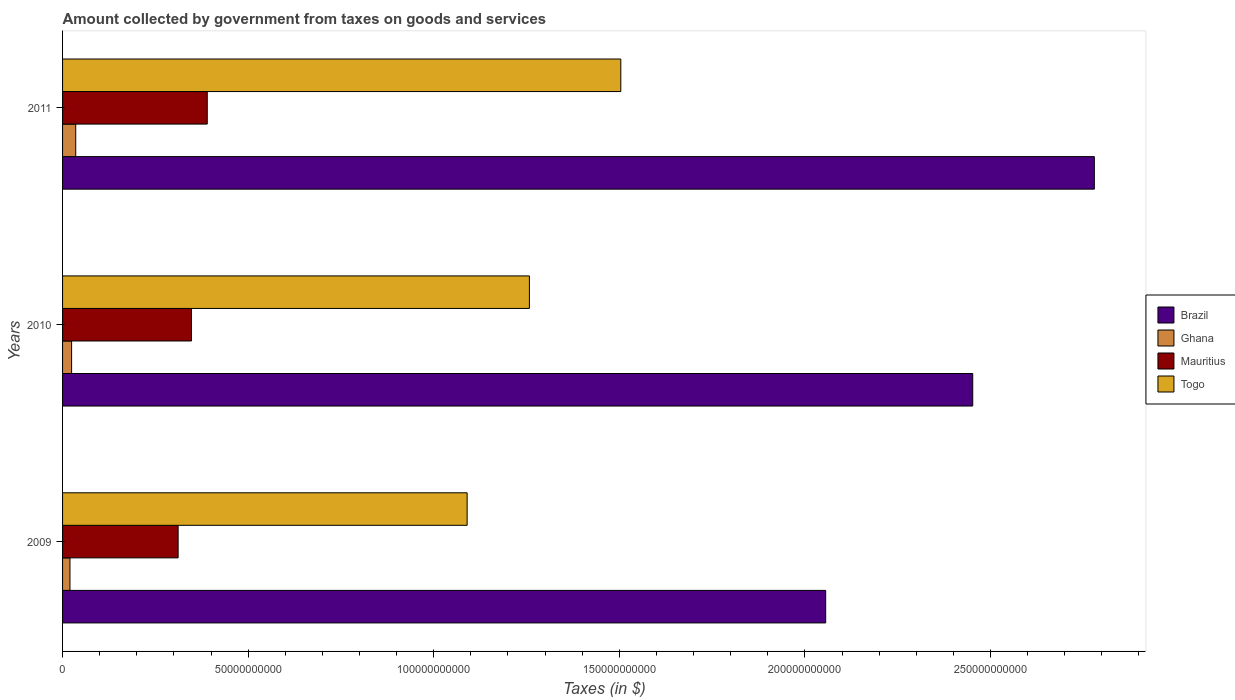How many different coloured bars are there?
Ensure brevity in your answer.  4. How many groups of bars are there?
Provide a short and direct response. 3. Are the number of bars on each tick of the Y-axis equal?
Provide a succinct answer. Yes. How many bars are there on the 3rd tick from the top?
Your response must be concise. 4. What is the label of the 3rd group of bars from the top?
Make the answer very short. 2009. What is the amount collected by government from taxes on goods and services in Togo in 2009?
Your answer should be very brief. 1.09e+11. Across all years, what is the maximum amount collected by government from taxes on goods and services in Mauritius?
Offer a terse response. 3.90e+1. Across all years, what is the minimum amount collected by government from taxes on goods and services in Mauritius?
Offer a very short reply. 3.11e+1. What is the total amount collected by government from taxes on goods and services in Brazil in the graph?
Your answer should be very brief. 7.29e+11. What is the difference between the amount collected by government from taxes on goods and services in Mauritius in 2010 and that in 2011?
Offer a terse response. -4.25e+09. What is the difference between the amount collected by government from taxes on goods and services in Brazil in 2010 and the amount collected by government from taxes on goods and services in Togo in 2011?
Provide a succinct answer. 9.48e+1. What is the average amount collected by government from taxes on goods and services in Mauritius per year?
Give a very brief answer. 3.50e+1. In the year 2010, what is the difference between the amount collected by government from taxes on goods and services in Togo and amount collected by government from taxes on goods and services in Mauritius?
Make the answer very short. 9.10e+1. What is the ratio of the amount collected by government from taxes on goods and services in Mauritius in 2009 to that in 2010?
Provide a succinct answer. 0.9. Is the amount collected by government from taxes on goods and services in Togo in 2010 less than that in 2011?
Offer a very short reply. Yes. What is the difference between the highest and the second highest amount collected by government from taxes on goods and services in Ghana?
Your response must be concise. 1.11e+09. What is the difference between the highest and the lowest amount collected by government from taxes on goods and services in Ghana?
Offer a terse response. 1.55e+09. Is the sum of the amount collected by government from taxes on goods and services in Mauritius in 2009 and 2010 greater than the maximum amount collected by government from taxes on goods and services in Togo across all years?
Your response must be concise. No. Is it the case that in every year, the sum of the amount collected by government from taxes on goods and services in Ghana and amount collected by government from taxes on goods and services in Togo is greater than the sum of amount collected by government from taxes on goods and services in Brazil and amount collected by government from taxes on goods and services in Mauritius?
Ensure brevity in your answer.  Yes. What does the 1st bar from the top in 2009 represents?
Provide a succinct answer. Togo. What does the 4th bar from the bottom in 2010 represents?
Offer a very short reply. Togo. Is it the case that in every year, the sum of the amount collected by government from taxes on goods and services in Togo and amount collected by government from taxes on goods and services in Mauritius is greater than the amount collected by government from taxes on goods and services in Brazil?
Ensure brevity in your answer.  No. Are all the bars in the graph horizontal?
Provide a short and direct response. Yes. How many years are there in the graph?
Offer a very short reply. 3. Does the graph contain grids?
Make the answer very short. No. Where does the legend appear in the graph?
Offer a terse response. Center right. What is the title of the graph?
Provide a short and direct response. Amount collected by government from taxes on goods and services. What is the label or title of the X-axis?
Your response must be concise. Taxes (in $). What is the Taxes (in $) in Brazil in 2009?
Offer a very short reply. 2.06e+11. What is the Taxes (in $) of Ghana in 2009?
Ensure brevity in your answer.  2.00e+09. What is the Taxes (in $) in Mauritius in 2009?
Make the answer very short. 3.11e+1. What is the Taxes (in $) in Togo in 2009?
Provide a succinct answer. 1.09e+11. What is the Taxes (in $) of Brazil in 2010?
Offer a terse response. 2.45e+11. What is the Taxes (in $) in Ghana in 2010?
Ensure brevity in your answer.  2.44e+09. What is the Taxes (in $) in Mauritius in 2010?
Your answer should be very brief. 3.47e+1. What is the Taxes (in $) in Togo in 2010?
Give a very brief answer. 1.26e+11. What is the Taxes (in $) of Brazil in 2011?
Your answer should be compact. 2.78e+11. What is the Taxes (in $) in Ghana in 2011?
Your answer should be very brief. 3.55e+09. What is the Taxes (in $) of Mauritius in 2011?
Give a very brief answer. 3.90e+1. What is the Taxes (in $) in Togo in 2011?
Ensure brevity in your answer.  1.50e+11. Across all years, what is the maximum Taxes (in $) in Brazil?
Offer a very short reply. 2.78e+11. Across all years, what is the maximum Taxes (in $) of Ghana?
Offer a very short reply. 3.55e+09. Across all years, what is the maximum Taxes (in $) of Mauritius?
Offer a very short reply. 3.90e+1. Across all years, what is the maximum Taxes (in $) of Togo?
Give a very brief answer. 1.50e+11. Across all years, what is the minimum Taxes (in $) in Brazil?
Your answer should be compact. 2.06e+11. Across all years, what is the minimum Taxes (in $) of Ghana?
Make the answer very short. 2.00e+09. Across all years, what is the minimum Taxes (in $) in Mauritius?
Provide a short and direct response. 3.11e+1. Across all years, what is the minimum Taxes (in $) in Togo?
Provide a short and direct response. 1.09e+11. What is the total Taxes (in $) of Brazil in the graph?
Your answer should be compact. 7.29e+11. What is the total Taxes (in $) in Ghana in the graph?
Your answer should be very brief. 7.98e+09. What is the total Taxes (in $) of Mauritius in the graph?
Give a very brief answer. 1.05e+11. What is the total Taxes (in $) of Togo in the graph?
Offer a terse response. 3.85e+11. What is the difference between the Taxes (in $) of Brazil in 2009 and that in 2010?
Keep it short and to the point. -3.96e+1. What is the difference between the Taxes (in $) in Ghana in 2009 and that in 2010?
Your response must be concise. -4.40e+08. What is the difference between the Taxes (in $) of Mauritius in 2009 and that in 2010?
Offer a very short reply. -3.60e+09. What is the difference between the Taxes (in $) of Togo in 2009 and that in 2010?
Your answer should be very brief. -1.68e+1. What is the difference between the Taxes (in $) in Brazil in 2009 and that in 2011?
Give a very brief answer. -7.24e+1. What is the difference between the Taxes (in $) in Ghana in 2009 and that in 2011?
Ensure brevity in your answer.  -1.55e+09. What is the difference between the Taxes (in $) of Mauritius in 2009 and that in 2011?
Your response must be concise. -7.85e+09. What is the difference between the Taxes (in $) of Togo in 2009 and that in 2011?
Offer a very short reply. -4.14e+1. What is the difference between the Taxes (in $) in Brazil in 2010 and that in 2011?
Make the answer very short. -3.28e+1. What is the difference between the Taxes (in $) of Ghana in 2010 and that in 2011?
Your answer should be very brief. -1.11e+09. What is the difference between the Taxes (in $) in Mauritius in 2010 and that in 2011?
Make the answer very short. -4.25e+09. What is the difference between the Taxes (in $) in Togo in 2010 and that in 2011?
Give a very brief answer. -2.46e+1. What is the difference between the Taxes (in $) of Brazil in 2009 and the Taxes (in $) of Ghana in 2010?
Make the answer very short. 2.03e+11. What is the difference between the Taxes (in $) of Brazil in 2009 and the Taxes (in $) of Mauritius in 2010?
Your answer should be compact. 1.71e+11. What is the difference between the Taxes (in $) of Brazil in 2009 and the Taxes (in $) of Togo in 2010?
Your answer should be very brief. 7.98e+1. What is the difference between the Taxes (in $) of Ghana in 2009 and the Taxes (in $) of Mauritius in 2010?
Your response must be concise. -3.27e+1. What is the difference between the Taxes (in $) in Ghana in 2009 and the Taxes (in $) in Togo in 2010?
Make the answer very short. -1.24e+11. What is the difference between the Taxes (in $) of Mauritius in 2009 and the Taxes (in $) of Togo in 2010?
Your answer should be compact. -9.46e+1. What is the difference between the Taxes (in $) in Brazil in 2009 and the Taxes (in $) in Ghana in 2011?
Your answer should be very brief. 2.02e+11. What is the difference between the Taxes (in $) of Brazil in 2009 and the Taxes (in $) of Mauritius in 2011?
Make the answer very short. 1.67e+11. What is the difference between the Taxes (in $) of Brazil in 2009 and the Taxes (in $) of Togo in 2011?
Offer a very short reply. 5.52e+1. What is the difference between the Taxes (in $) in Ghana in 2009 and the Taxes (in $) in Mauritius in 2011?
Ensure brevity in your answer.  -3.70e+1. What is the difference between the Taxes (in $) in Ghana in 2009 and the Taxes (in $) in Togo in 2011?
Provide a short and direct response. -1.48e+11. What is the difference between the Taxes (in $) of Mauritius in 2009 and the Taxes (in $) of Togo in 2011?
Your response must be concise. -1.19e+11. What is the difference between the Taxes (in $) in Brazil in 2010 and the Taxes (in $) in Ghana in 2011?
Ensure brevity in your answer.  2.42e+11. What is the difference between the Taxes (in $) of Brazil in 2010 and the Taxes (in $) of Mauritius in 2011?
Make the answer very short. 2.06e+11. What is the difference between the Taxes (in $) of Brazil in 2010 and the Taxes (in $) of Togo in 2011?
Provide a succinct answer. 9.48e+1. What is the difference between the Taxes (in $) in Ghana in 2010 and the Taxes (in $) in Mauritius in 2011?
Ensure brevity in your answer.  -3.65e+1. What is the difference between the Taxes (in $) in Ghana in 2010 and the Taxes (in $) in Togo in 2011?
Your response must be concise. -1.48e+11. What is the difference between the Taxes (in $) in Mauritius in 2010 and the Taxes (in $) in Togo in 2011?
Keep it short and to the point. -1.16e+11. What is the average Taxes (in $) of Brazil per year?
Provide a succinct answer. 2.43e+11. What is the average Taxes (in $) of Ghana per year?
Ensure brevity in your answer.  2.66e+09. What is the average Taxes (in $) in Mauritius per year?
Make the answer very short. 3.50e+1. What is the average Taxes (in $) of Togo per year?
Your response must be concise. 1.28e+11. In the year 2009, what is the difference between the Taxes (in $) in Brazil and Taxes (in $) in Ghana?
Offer a very short reply. 2.04e+11. In the year 2009, what is the difference between the Taxes (in $) in Brazil and Taxes (in $) in Mauritius?
Offer a terse response. 1.74e+11. In the year 2009, what is the difference between the Taxes (in $) of Brazil and Taxes (in $) of Togo?
Offer a terse response. 9.66e+1. In the year 2009, what is the difference between the Taxes (in $) of Ghana and Taxes (in $) of Mauritius?
Your answer should be compact. -2.91e+1. In the year 2009, what is the difference between the Taxes (in $) in Ghana and Taxes (in $) in Togo?
Your answer should be very brief. -1.07e+11. In the year 2009, what is the difference between the Taxes (in $) in Mauritius and Taxes (in $) in Togo?
Ensure brevity in your answer.  -7.79e+1. In the year 2010, what is the difference between the Taxes (in $) in Brazil and Taxes (in $) in Ghana?
Provide a succinct answer. 2.43e+11. In the year 2010, what is the difference between the Taxes (in $) of Brazil and Taxes (in $) of Mauritius?
Offer a terse response. 2.10e+11. In the year 2010, what is the difference between the Taxes (in $) in Brazil and Taxes (in $) in Togo?
Ensure brevity in your answer.  1.19e+11. In the year 2010, what is the difference between the Taxes (in $) in Ghana and Taxes (in $) in Mauritius?
Give a very brief answer. -3.23e+1. In the year 2010, what is the difference between the Taxes (in $) of Ghana and Taxes (in $) of Togo?
Your answer should be compact. -1.23e+11. In the year 2010, what is the difference between the Taxes (in $) of Mauritius and Taxes (in $) of Togo?
Provide a short and direct response. -9.10e+1. In the year 2011, what is the difference between the Taxes (in $) of Brazil and Taxes (in $) of Ghana?
Ensure brevity in your answer.  2.74e+11. In the year 2011, what is the difference between the Taxes (in $) in Brazil and Taxes (in $) in Mauritius?
Give a very brief answer. 2.39e+11. In the year 2011, what is the difference between the Taxes (in $) of Brazil and Taxes (in $) of Togo?
Offer a terse response. 1.28e+11. In the year 2011, what is the difference between the Taxes (in $) of Ghana and Taxes (in $) of Mauritius?
Your answer should be very brief. -3.54e+1. In the year 2011, what is the difference between the Taxes (in $) of Ghana and Taxes (in $) of Togo?
Your answer should be compact. -1.47e+11. In the year 2011, what is the difference between the Taxes (in $) in Mauritius and Taxes (in $) in Togo?
Make the answer very short. -1.11e+11. What is the ratio of the Taxes (in $) of Brazil in 2009 to that in 2010?
Your answer should be very brief. 0.84. What is the ratio of the Taxes (in $) in Ghana in 2009 to that in 2010?
Offer a very short reply. 0.82. What is the ratio of the Taxes (in $) of Mauritius in 2009 to that in 2010?
Ensure brevity in your answer.  0.9. What is the ratio of the Taxes (in $) in Togo in 2009 to that in 2010?
Offer a terse response. 0.87. What is the ratio of the Taxes (in $) in Brazil in 2009 to that in 2011?
Your response must be concise. 0.74. What is the ratio of the Taxes (in $) in Ghana in 2009 to that in 2011?
Provide a succinct answer. 0.56. What is the ratio of the Taxes (in $) of Mauritius in 2009 to that in 2011?
Give a very brief answer. 0.8. What is the ratio of the Taxes (in $) in Togo in 2009 to that in 2011?
Offer a terse response. 0.72. What is the ratio of the Taxes (in $) of Brazil in 2010 to that in 2011?
Provide a short and direct response. 0.88. What is the ratio of the Taxes (in $) of Ghana in 2010 to that in 2011?
Your answer should be compact. 0.69. What is the ratio of the Taxes (in $) in Mauritius in 2010 to that in 2011?
Provide a short and direct response. 0.89. What is the ratio of the Taxes (in $) in Togo in 2010 to that in 2011?
Your answer should be very brief. 0.84. What is the difference between the highest and the second highest Taxes (in $) in Brazil?
Give a very brief answer. 3.28e+1. What is the difference between the highest and the second highest Taxes (in $) of Ghana?
Provide a short and direct response. 1.11e+09. What is the difference between the highest and the second highest Taxes (in $) in Mauritius?
Offer a very short reply. 4.25e+09. What is the difference between the highest and the second highest Taxes (in $) of Togo?
Your answer should be compact. 2.46e+1. What is the difference between the highest and the lowest Taxes (in $) of Brazil?
Provide a short and direct response. 7.24e+1. What is the difference between the highest and the lowest Taxes (in $) of Ghana?
Your answer should be very brief. 1.55e+09. What is the difference between the highest and the lowest Taxes (in $) in Mauritius?
Provide a short and direct response. 7.85e+09. What is the difference between the highest and the lowest Taxes (in $) of Togo?
Your answer should be compact. 4.14e+1. 